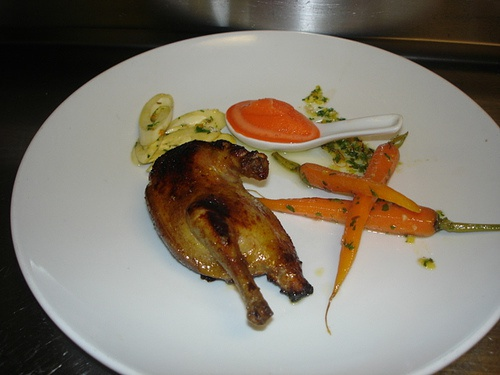Describe the objects in this image and their specific colors. I can see dining table in darkgray, black, lightgray, and brown tones, spoon in black, brown, darkgray, and gray tones, carrot in black, brown, maroon, and olive tones, carrot in black, brown, maroon, and darkgray tones, and carrot in black, brown, and maroon tones in this image. 